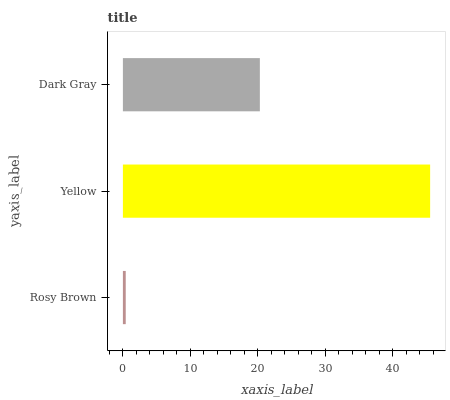Is Rosy Brown the minimum?
Answer yes or no. Yes. Is Yellow the maximum?
Answer yes or no. Yes. Is Dark Gray the minimum?
Answer yes or no. No. Is Dark Gray the maximum?
Answer yes or no. No. Is Yellow greater than Dark Gray?
Answer yes or no. Yes. Is Dark Gray less than Yellow?
Answer yes or no. Yes. Is Dark Gray greater than Yellow?
Answer yes or no. No. Is Yellow less than Dark Gray?
Answer yes or no. No. Is Dark Gray the high median?
Answer yes or no. Yes. Is Dark Gray the low median?
Answer yes or no. Yes. Is Rosy Brown the high median?
Answer yes or no. No. Is Yellow the low median?
Answer yes or no. No. 